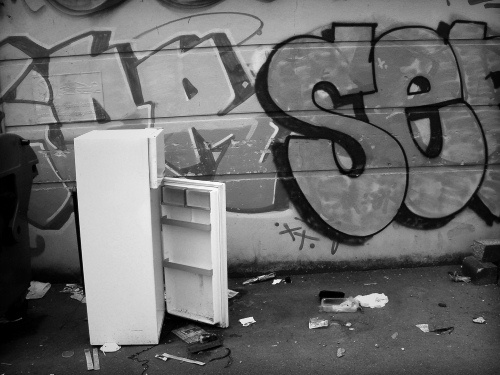Describe the objects in this image and their specific colors. I can see a refrigerator in black, lightgray, darkgray, and gray tones in this image. 